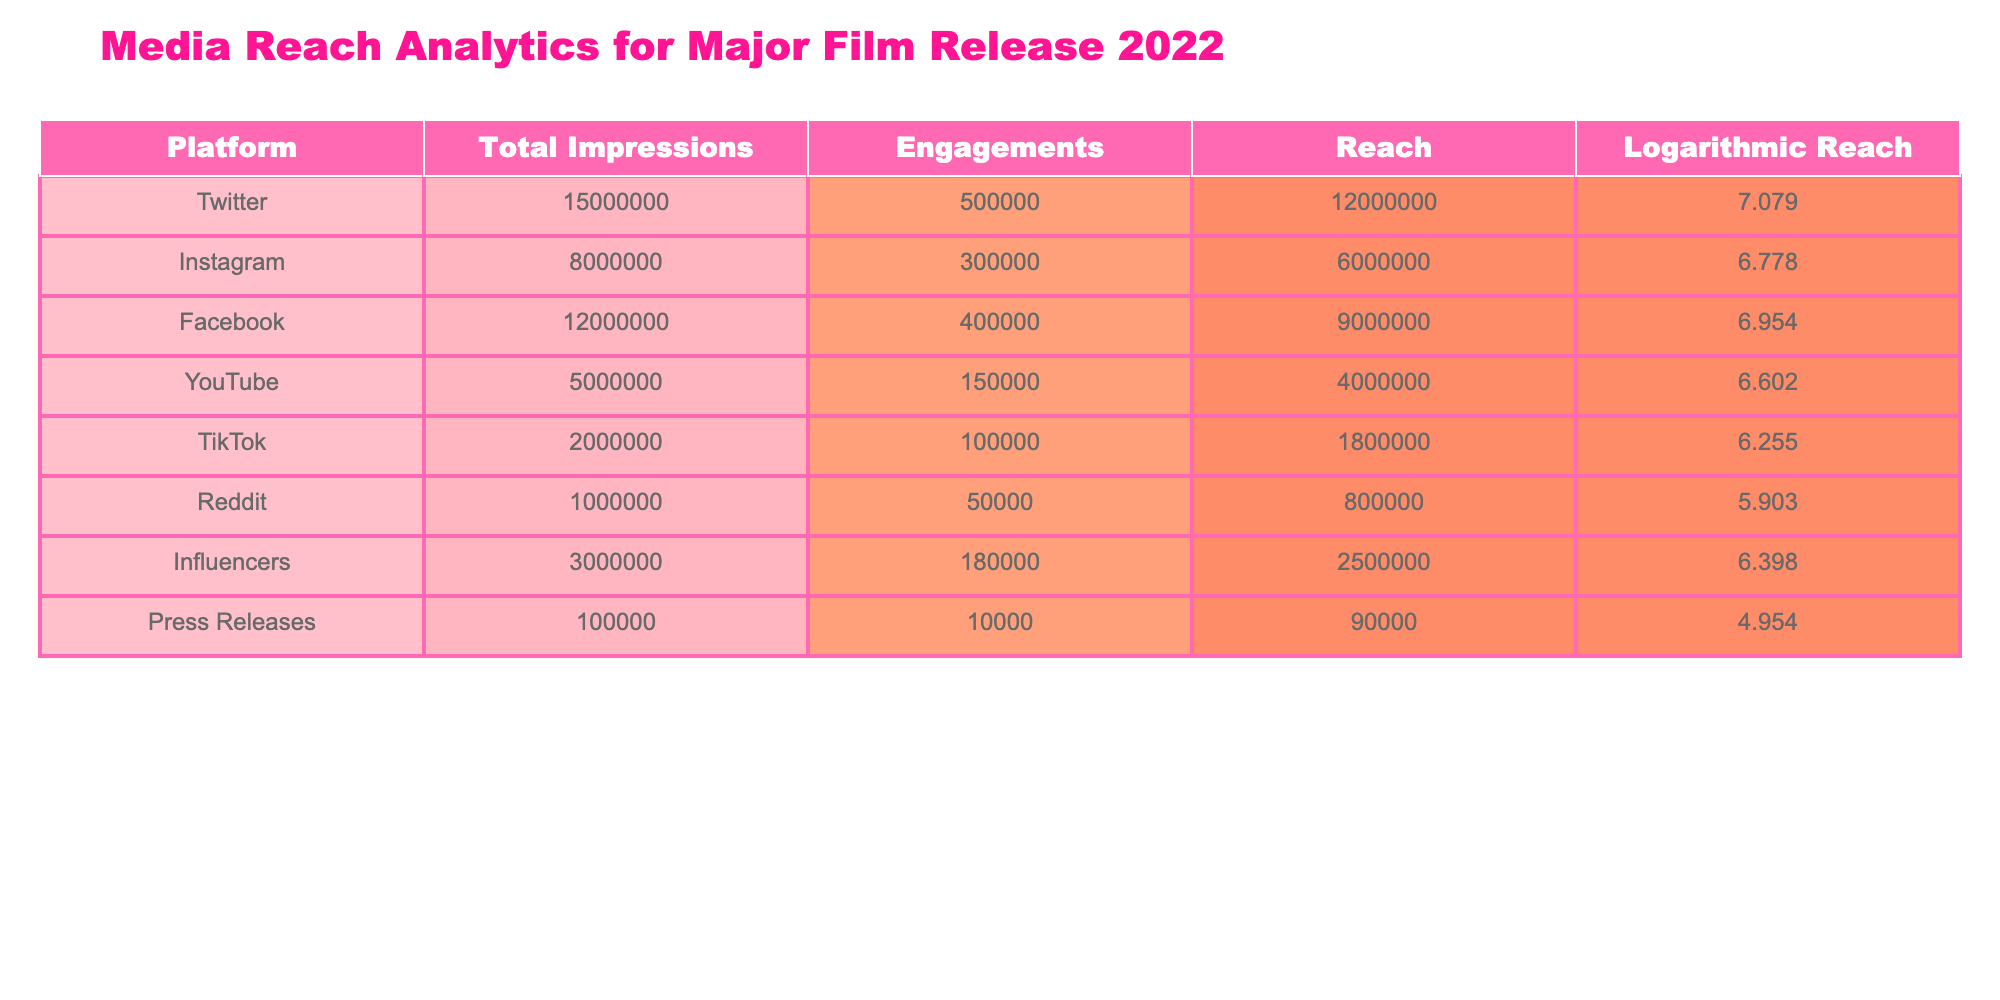What platform had the highest total impressions? According to the table, Twitter has the highest total impressions with a value of 15,000,000.
Answer: Twitter What is the engagement rate for Instagram? The engagement rate is calculated as Engagements divided by Total Impressions, (300,000 / 8,000,000) * 100 = 3.75%.
Answer: 3.75% Did TikTok have more reach than Reddit? TikTok's reach is 1,800,000, while Reddit's reach is 800,000. Since 1,800,000 is greater than 800,000, the statement is true.
Answer: Yes Which platform had the lowest logarithmic reach? The logarithmic reach for each platform is listed, and Reddit has the lowest value at 5.903.
Answer: Reddit If we sum the total impressions of YouTube and TikTok, what is the total? Total impressions for YouTube is 5,000,000, and for TikTok, it is 2,000,000. The sum is 5,000,000 + 2,000,000 = 7,000,000.
Answer: 7,000,000 Is the total reach of Influencers greater than the total reach of Facebook? Influencers have a reach of 2,500,000, while Facebook has a reach of 9,000,000. Since 2,500,000 is less than 9,000,000, the claim is false.
Answer: No What is the difference in engagements between Twitter and Instagram? Twitter has 500,000 engagements and Instagram has 300,000. The difference is 500,000 - 300,000 = 200,000 engagements.
Answer: 200,000 Which platform has a logarithmic reach above 6.5? The platforms with logarithmic reach above 6.5 are Twitter (7.079), Facebook (6.954), Instagram (6.778), and Influencers (6.398).
Answer: Twitter, Facebook, Instagram What is the average reach of the platforms listed in the table? To find the average reach, we sum the reach of all platforms: 12,000,000 + 6,000,000 + 9,000,000 + 4,000,000 + 1,800,000 + 800,000 + 2,500,000 + 90,000 = 36,190,000. There are 8 platforms, so the average is 36,190,000 / 8 = 4,523,750.
Answer: 4,523,750 